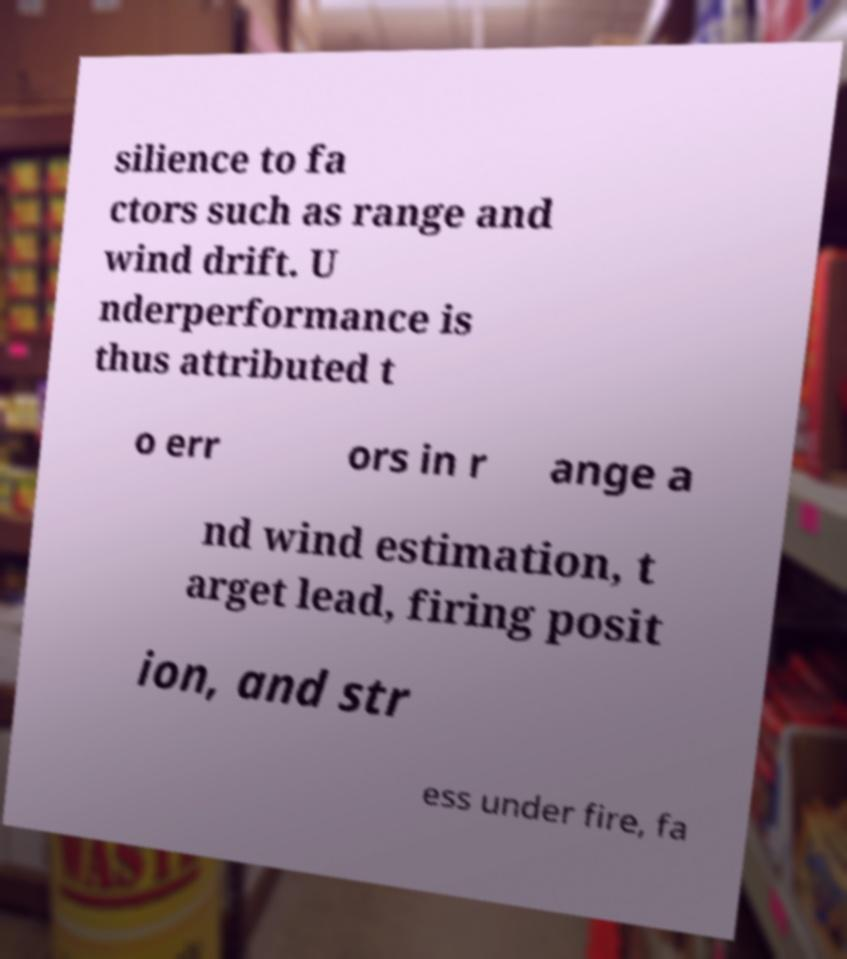For documentation purposes, I need the text within this image transcribed. Could you provide that? silience to fa ctors such as range and wind drift. U nderperformance is thus attributed t o err ors in r ange a nd wind estimation, t arget lead, firing posit ion, and str ess under fire, fa 